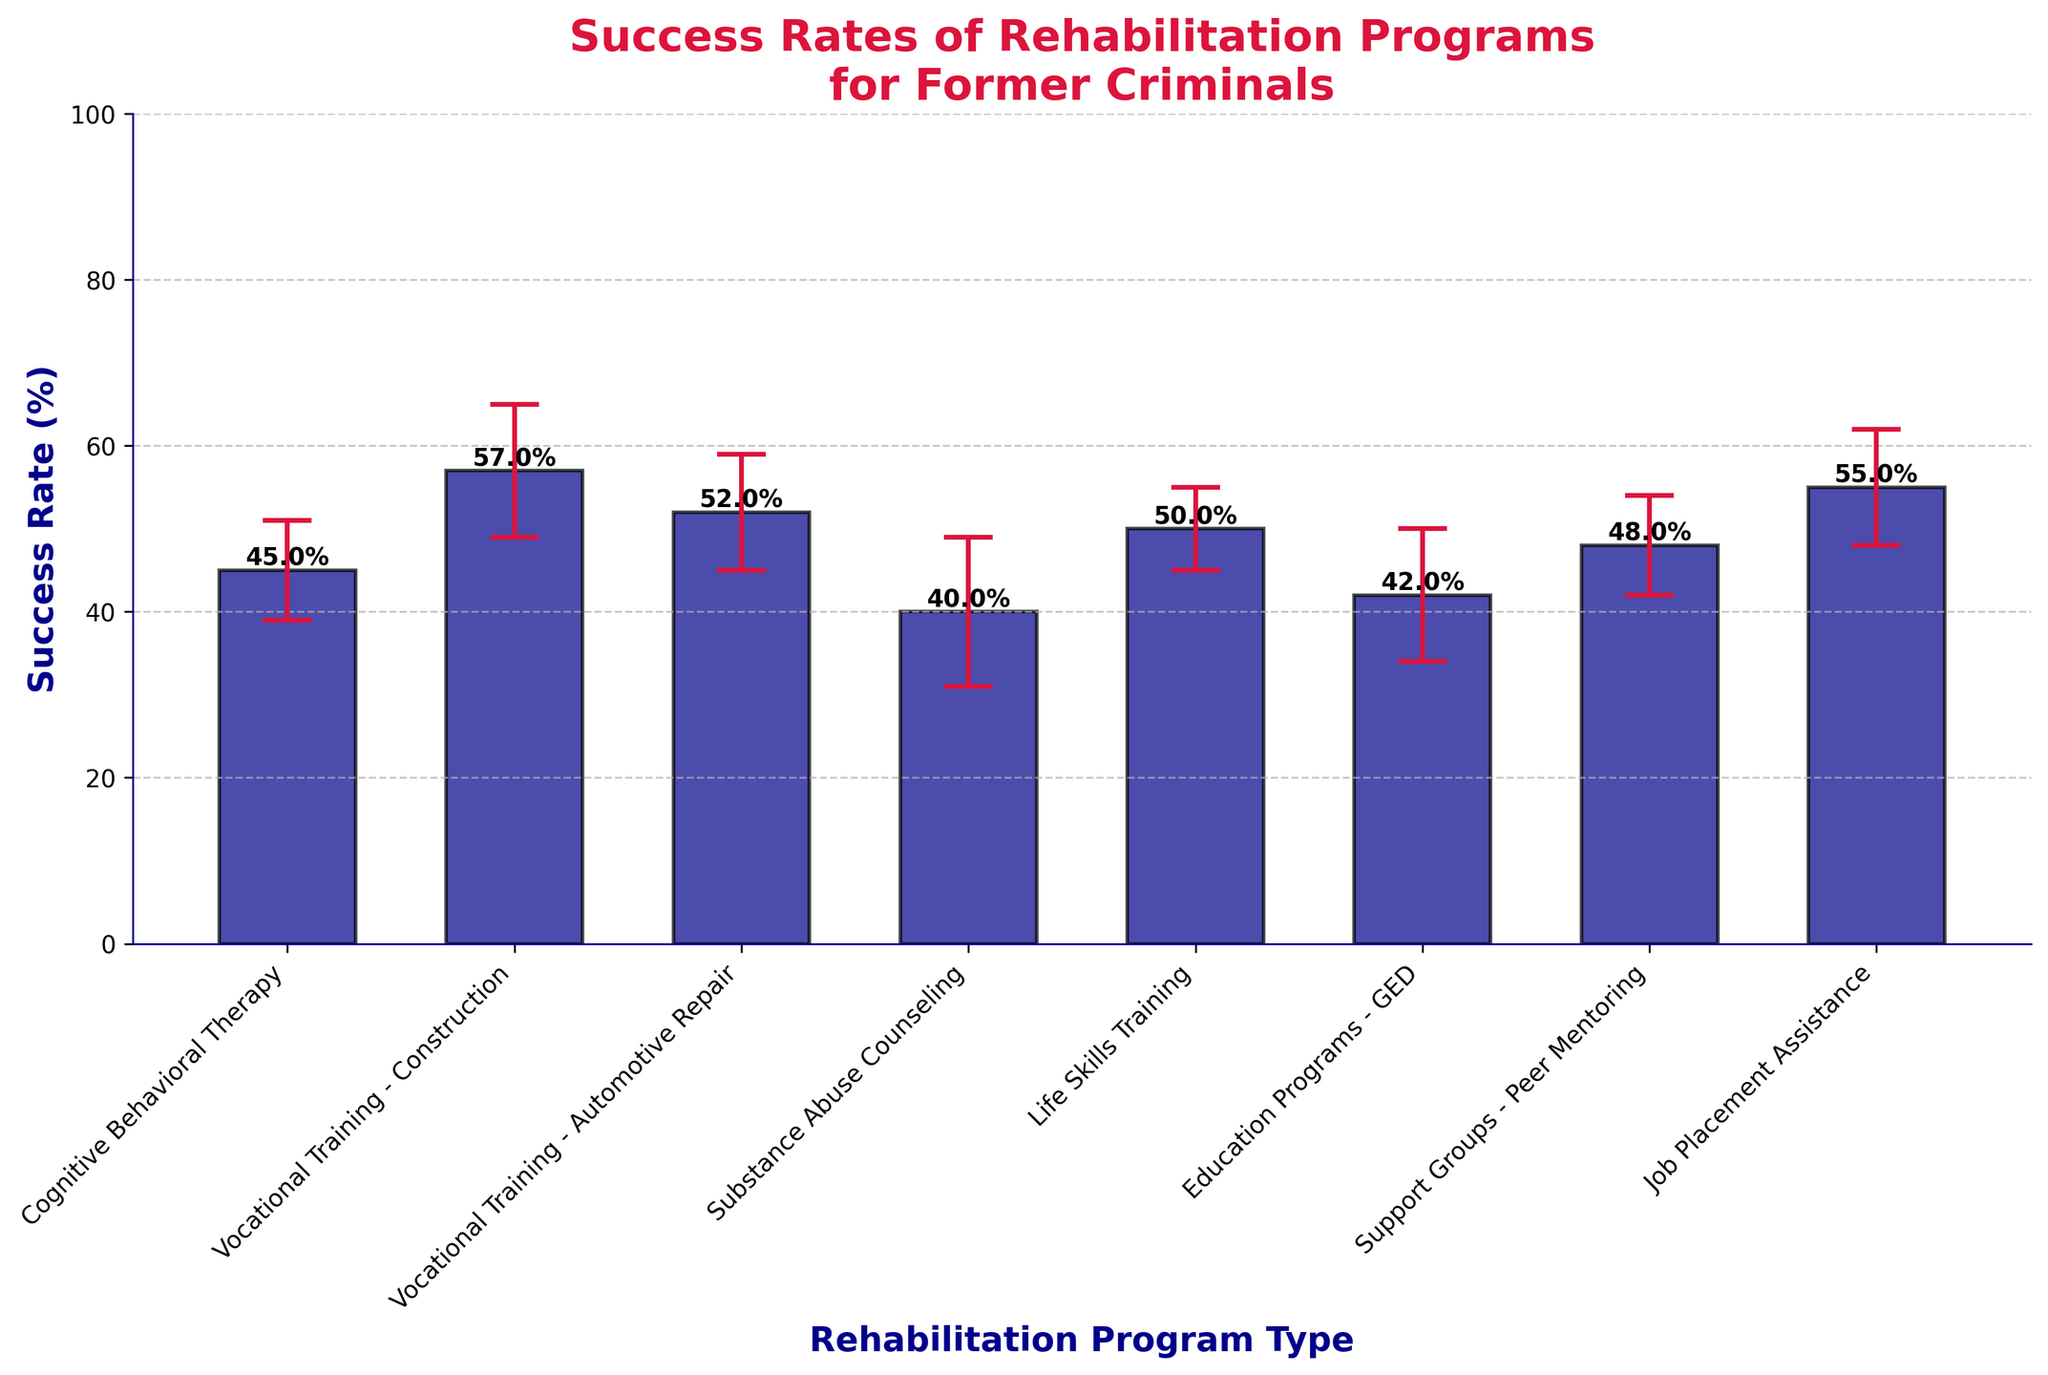What is the success rate of Cognitive Behavioral Therapy? The bar for Cognitive Behavioral Therapy indicates a success rate of 45%, as labeled directly on the bar.
Answer: 45% Which rehabilitation program has the highest success rate? Vocational Training - Construction has the highest success rate, shown by the tallest bar with 57%.
Answer: Vocational Training - Construction What is the difference in success rates between Life Skills Training and Education Programs - GED? Life Skills Training has a success rate of 50%, while Education Programs - GED has 42%. The difference is 50% - 42% = 8%.
Answer: 8% Which program has the lowest success rate and what is it? Substance Abuse Counseling has the lowest success rate, shown by the shortest bar with 40%.
Answer: Substance Abuse Counseling, 40% What is the average success rate of all vocational training programs combined? Vocational Training - Construction has a success rate of 57%, and Vocational Training - Automotive Repair has 52%. The average is (57 + 52) / 2 = 54.5%.
Answer: 54.5% How does the success rate of Job Placement Assistance compare to Cognitive Behavioral Therapy? Job Placement Assistance has a success rate of 55%, which is 10% higher than Cognitive Behavioral Therapy's 45%.
Answer: Job Placement Assistance is 10% higher than Cognitive Behavioral Therapy What is the combined error bar range for Education Programs - GED? Education Programs - GED has a success rate of 42% with a standard deviation of 8%. The error bar range is from 42% - 8% to 42% + 8%, which equals 34% to 50%.
Answer: 34% to 50% Which program has more variability in its success rate: Support Groups - Peer Mentoring or Life Skills Training? Support Groups - Peer Mentoring has a standard deviation of 6%, and Life Skills Training has 5%. Therefore, Support Groups - Peer Mentoring has more variability.
Answer: Support Groups - Peer Mentoring What is the success rate range for Vocational Training - Automotive Repair? Vocational Training - Automotive Repair has a success rate of 52% with a standard deviation of 7%. The range is from 52% - 7% to 52% + 7%, which equals 45% to 59%.
Answer: 45% to 59% How many programs have a success rate equal to or greater than 50%? The programs with a success rate equal to or greater than 50% are: Vocational Training - Construction (57%), Vocational Training - Automotive Repair (52%), Life Skills Training (50%), and Job Placement Assistance (55%). There are 4 such programs.
Answer: 4 